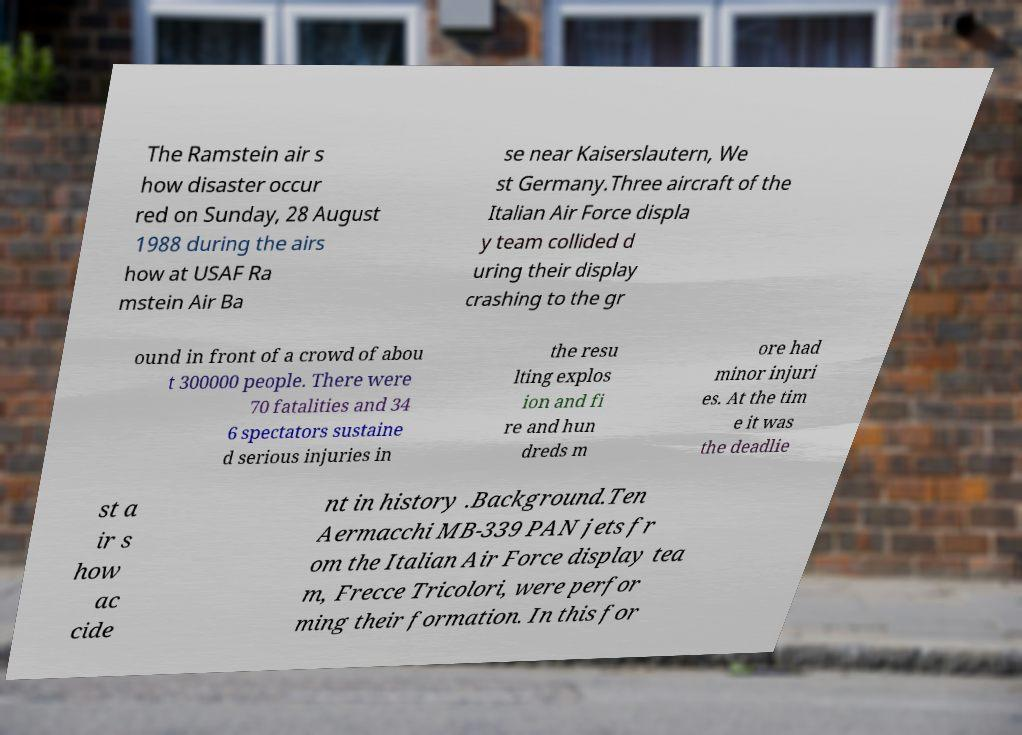Could you assist in decoding the text presented in this image and type it out clearly? The Ramstein air s how disaster occur red on Sunday, 28 August 1988 during the airs how at USAF Ra mstein Air Ba se near Kaiserslautern, We st Germany.Three aircraft of the Italian Air Force displa y team collided d uring their display crashing to the gr ound in front of a crowd of abou t 300000 people. There were 70 fatalities and 34 6 spectators sustaine d serious injuries in the resu lting explos ion and fi re and hun dreds m ore had minor injuri es. At the tim e it was the deadlie st a ir s how ac cide nt in history .Background.Ten Aermacchi MB-339 PAN jets fr om the Italian Air Force display tea m, Frecce Tricolori, were perfor ming their formation. In this for 